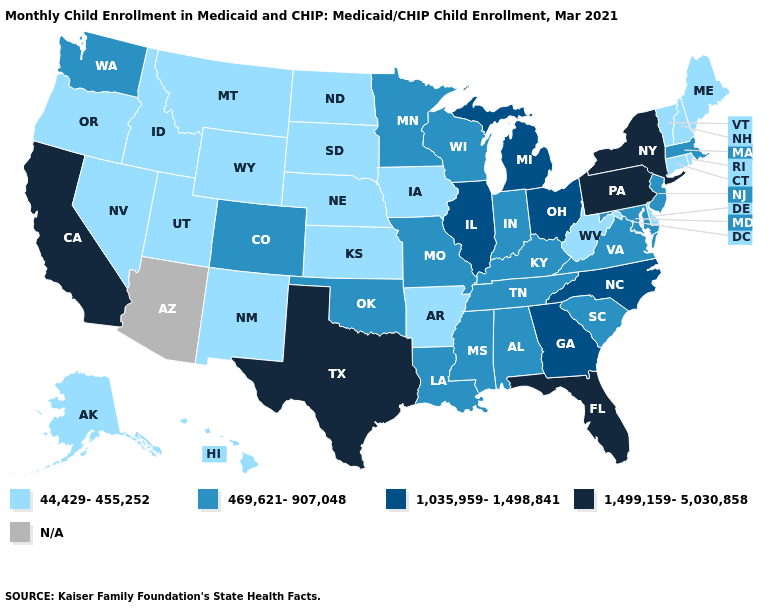Name the states that have a value in the range 44,429-455,252?
Be succinct. Alaska, Arkansas, Connecticut, Delaware, Hawaii, Idaho, Iowa, Kansas, Maine, Montana, Nebraska, Nevada, New Hampshire, New Mexico, North Dakota, Oregon, Rhode Island, South Dakota, Utah, Vermont, West Virginia, Wyoming. Which states have the lowest value in the USA?
Short answer required. Alaska, Arkansas, Connecticut, Delaware, Hawaii, Idaho, Iowa, Kansas, Maine, Montana, Nebraska, Nevada, New Hampshire, New Mexico, North Dakota, Oregon, Rhode Island, South Dakota, Utah, Vermont, West Virginia, Wyoming. What is the value of Oregon?
Write a very short answer. 44,429-455,252. Name the states that have a value in the range 469,621-907,048?
Give a very brief answer. Alabama, Colorado, Indiana, Kentucky, Louisiana, Maryland, Massachusetts, Minnesota, Mississippi, Missouri, New Jersey, Oklahoma, South Carolina, Tennessee, Virginia, Washington, Wisconsin. What is the value of Florida?
Quick response, please. 1,499,159-5,030,858. What is the value of Tennessee?
Be succinct. 469,621-907,048. Does Maryland have the lowest value in the South?
Write a very short answer. No. Does the first symbol in the legend represent the smallest category?
Keep it brief. Yes. Name the states that have a value in the range 1,499,159-5,030,858?
Answer briefly. California, Florida, New York, Pennsylvania, Texas. Name the states that have a value in the range 44,429-455,252?
Answer briefly. Alaska, Arkansas, Connecticut, Delaware, Hawaii, Idaho, Iowa, Kansas, Maine, Montana, Nebraska, Nevada, New Hampshire, New Mexico, North Dakota, Oregon, Rhode Island, South Dakota, Utah, Vermont, West Virginia, Wyoming. Does the map have missing data?
Be succinct. Yes. Which states have the highest value in the USA?
Answer briefly. California, Florida, New York, Pennsylvania, Texas. Name the states that have a value in the range 469,621-907,048?
Short answer required. Alabama, Colorado, Indiana, Kentucky, Louisiana, Maryland, Massachusetts, Minnesota, Mississippi, Missouri, New Jersey, Oklahoma, South Carolina, Tennessee, Virginia, Washington, Wisconsin. How many symbols are there in the legend?
Be succinct. 5. What is the lowest value in the Northeast?
Short answer required. 44,429-455,252. 